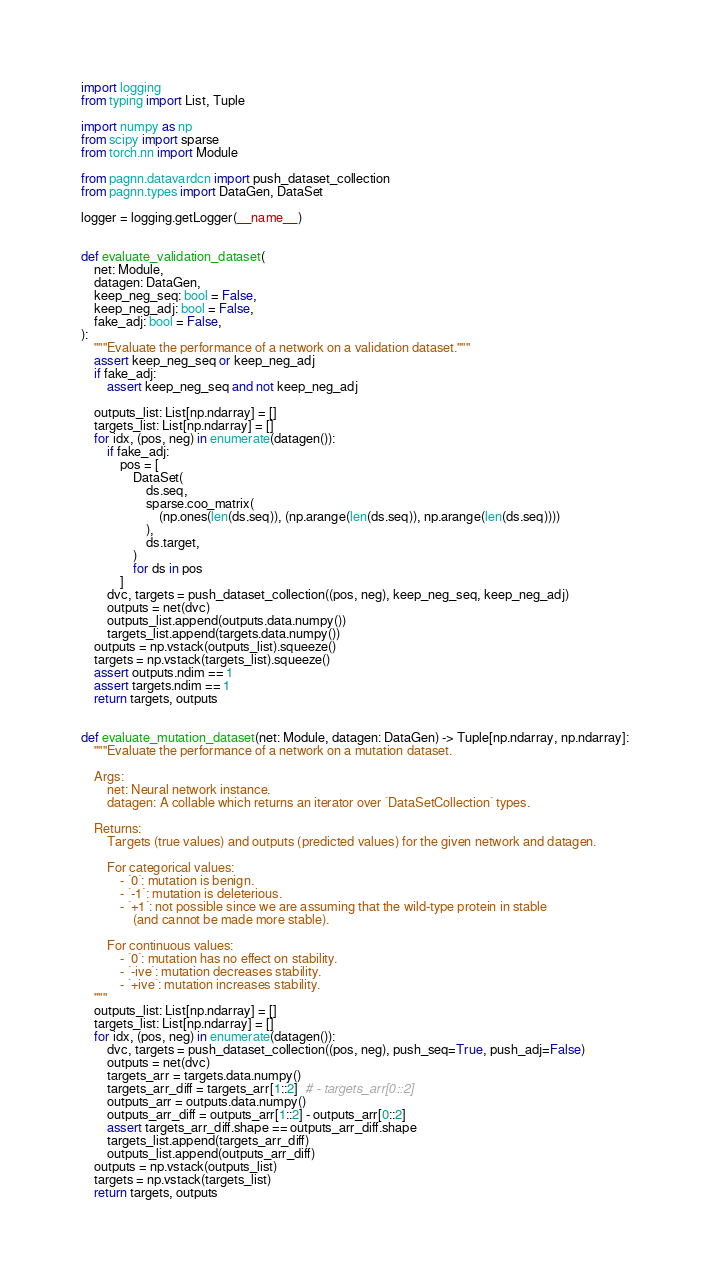<code> <loc_0><loc_0><loc_500><loc_500><_Python_>import logging
from typing import List, Tuple

import numpy as np
from scipy import sparse
from torch.nn import Module

from pagnn.datavardcn import push_dataset_collection
from pagnn.types import DataGen, DataSet

logger = logging.getLogger(__name__)


def evaluate_validation_dataset(
    net: Module,
    datagen: DataGen,
    keep_neg_seq: bool = False,
    keep_neg_adj: bool = False,
    fake_adj: bool = False,
):
    """Evaluate the performance of a network on a validation dataset."""
    assert keep_neg_seq or keep_neg_adj
    if fake_adj:
        assert keep_neg_seq and not keep_neg_adj

    outputs_list: List[np.ndarray] = []
    targets_list: List[np.ndarray] = []
    for idx, (pos, neg) in enumerate(datagen()):
        if fake_adj:
            pos = [
                DataSet(
                    ds.seq,
                    sparse.coo_matrix(
                        (np.ones(len(ds.seq)), (np.arange(len(ds.seq)), np.arange(len(ds.seq))))
                    ),
                    ds.target,
                )
                for ds in pos
            ]
        dvc, targets = push_dataset_collection((pos, neg), keep_neg_seq, keep_neg_adj)
        outputs = net(dvc)
        outputs_list.append(outputs.data.numpy())
        targets_list.append(targets.data.numpy())
    outputs = np.vstack(outputs_list).squeeze()
    targets = np.vstack(targets_list).squeeze()
    assert outputs.ndim == 1
    assert targets.ndim == 1
    return targets, outputs


def evaluate_mutation_dataset(net: Module, datagen: DataGen) -> Tuple[np.ndarray, np.ndarray]:
    """Evaluate the performance of a network on a mutation dataset.

    Args:
        net: Neural network instance.
        datagen: A collable which returns an iterator over `DataSetCollection` types.

    Returns:
        Targets (true values) and outputs (predicted values) for the given network and datagen.

        For categorical values:
            - `0`: mutation is benign.
            - `-1`: mutation is deleterious.
            - `+1`: not possible since we are assuming that the wild-type protein in stable
                (and cannot be made more stable).

        For continuous values:
            - `0`: mutation has no effect on stability.
            - `-ive`: mutation decreases stability.
            - `+ive`: mutation increases stability.
    """
    outputs_list: List[np.ndarray] = []
    targets_list: List[np.ndarray] = []
    for idx, (pos, neg) in enumerate(datagen()):
        dvc, targets = push_dataset_collection((pos, neg), push_seq=True, push_adj=False)
        outputs = net(dvc)
        targets_arr = targets.data.numpy()
        targets_arr_diff = targets_arr[1::2]  # - targets_arr[0::2]
        outputs_arr = outputs.data.numpy()
        outputs_arr_diff = outputs_arr[1::2] - outputs_arr[0::2]
        assert targets_arr_diff.shape == outputs_arr_diff.shape
        targets_list.append(targets_arr_diff)
        outputs_list.append(outputs_arr_diff)
    outputs = np.vstack(outputs_list)
    targets = np.vstack(targets_list)
    return targets, outputs
</code> 